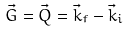Convert formula to latex. <formula><loc_0><loc_0><loc_500><loc_500>\vec { G } = \vec { Q } = \vec { k } _ { f } - \vec { k } _ { i }</formula> 